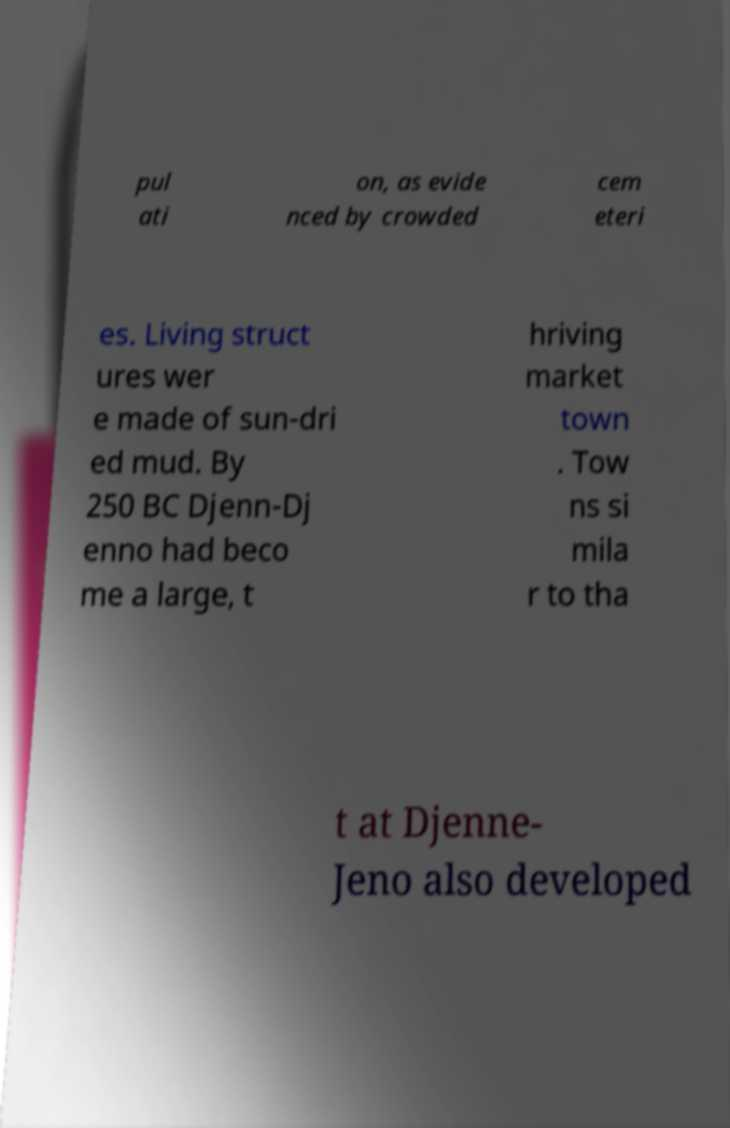Could you extract and type out the text from this image? pul ati on, as evide nced by crowded cem eteri es. Living struct ures wer e made of sun-dri ed mud. By 250 BC Djenn-Dj enno had beco me a large, t hriving market town . Tow ns si mila r to tha t at Djenne- Jeno also developed 